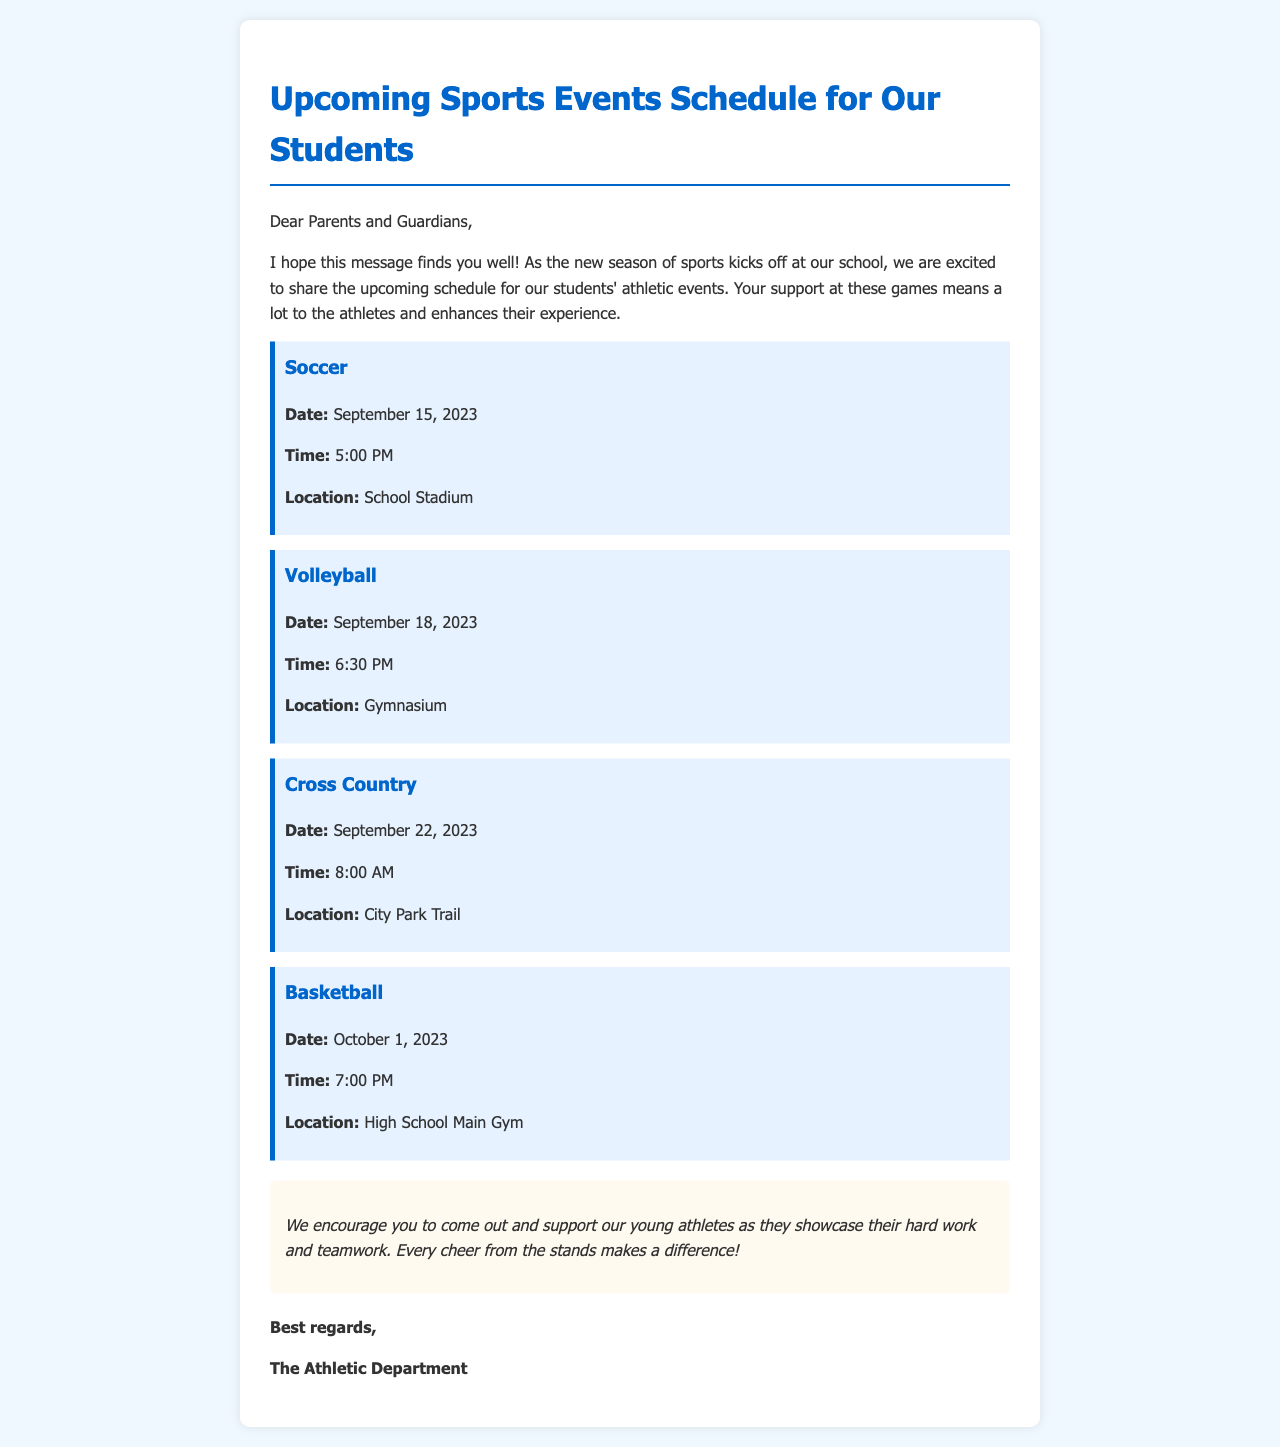What is the date of the soccer match? The date of the soccer match is explicitly mentioned in the document, which is September 15, 2023.
Answer: September 15, 2023 What time does the volleyball game start? The document specifies that the volleyball game starts at 6:30 PM.
Answer: 6:30 PM Where will the cross country event take place? The location for the cross country event is stated as City Park Trail in the document.
Answer: City Park Trail How many sports events are listed in the schedule? The document lists a total of four sports events in the schedule.
Answer: Four What is the location for the basketball game? The document specifies that the basketball game will take place in the High School Main Gym.
Answer: High School Main Gym What should parents do to support the athletes? The document encourages parents to come out and cheer for the athletes, emphasizing the importance of support.
Answer: Come out and support Which sport occurs last in the schedule? Analyzing the dates listed, basketball occurs last in the schedule on October 1, 2023.
Answer: Basketball What organization is sending this email? The sender of the email is identified as the Athletic Department in the document.
Answer: The Athletic Department 